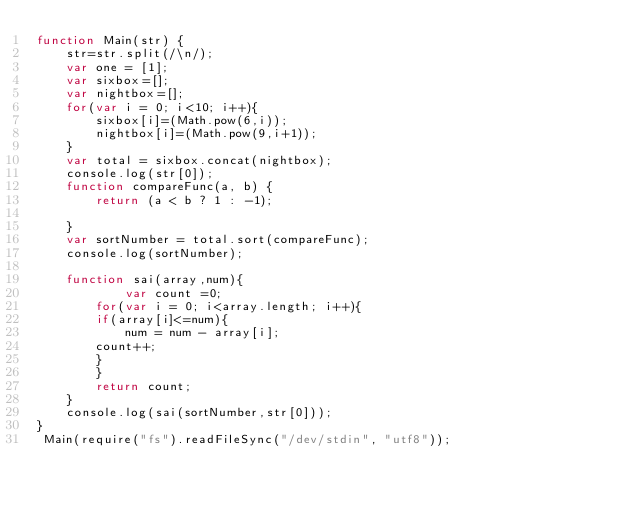Convert code to text. <code><loc_0><loc_0><loc_500><loc_500><_JavaScript_>function Main(str) {
    str=str.split(/\n/);
    var one = [1];
    var sixbox=[];
    var nightbox=[];
    for(var i = 0; i<10; i++){
        sixbox[i]=(Math.pow(6,i));
        nightbox[i]=(Math.pow(9,i+1));
    }
    var total = sixbox.concat(nightbox);
    console.log(str[0]);
    function compareFunc(a, b) {
        return (a < b ? 1 : -1);
        
    }
    var sortNumber = total.sort(compareFunc);
    console.log(sortNumber);
    
    function sai(array,num){
            var count =0;
        for(var i = 0; i<array.length; i++){
        if(array[i]<=num){
            num = num - array[i];
        count++;
        }
        }
        return count;
    }
    console.log(sai(sortNumber,str[0]));
}
 Main(require("fs").readFileSync("/dev/stdin", "utf8"));</code> 